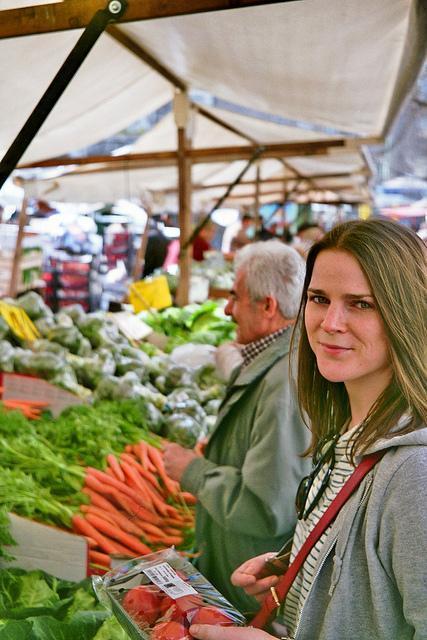Which food contains the most vitamin A?
Pick the correct solution from the four options below to address the question.
Options: Tomato, lettuce, carrot, broccoli. Carrot. 